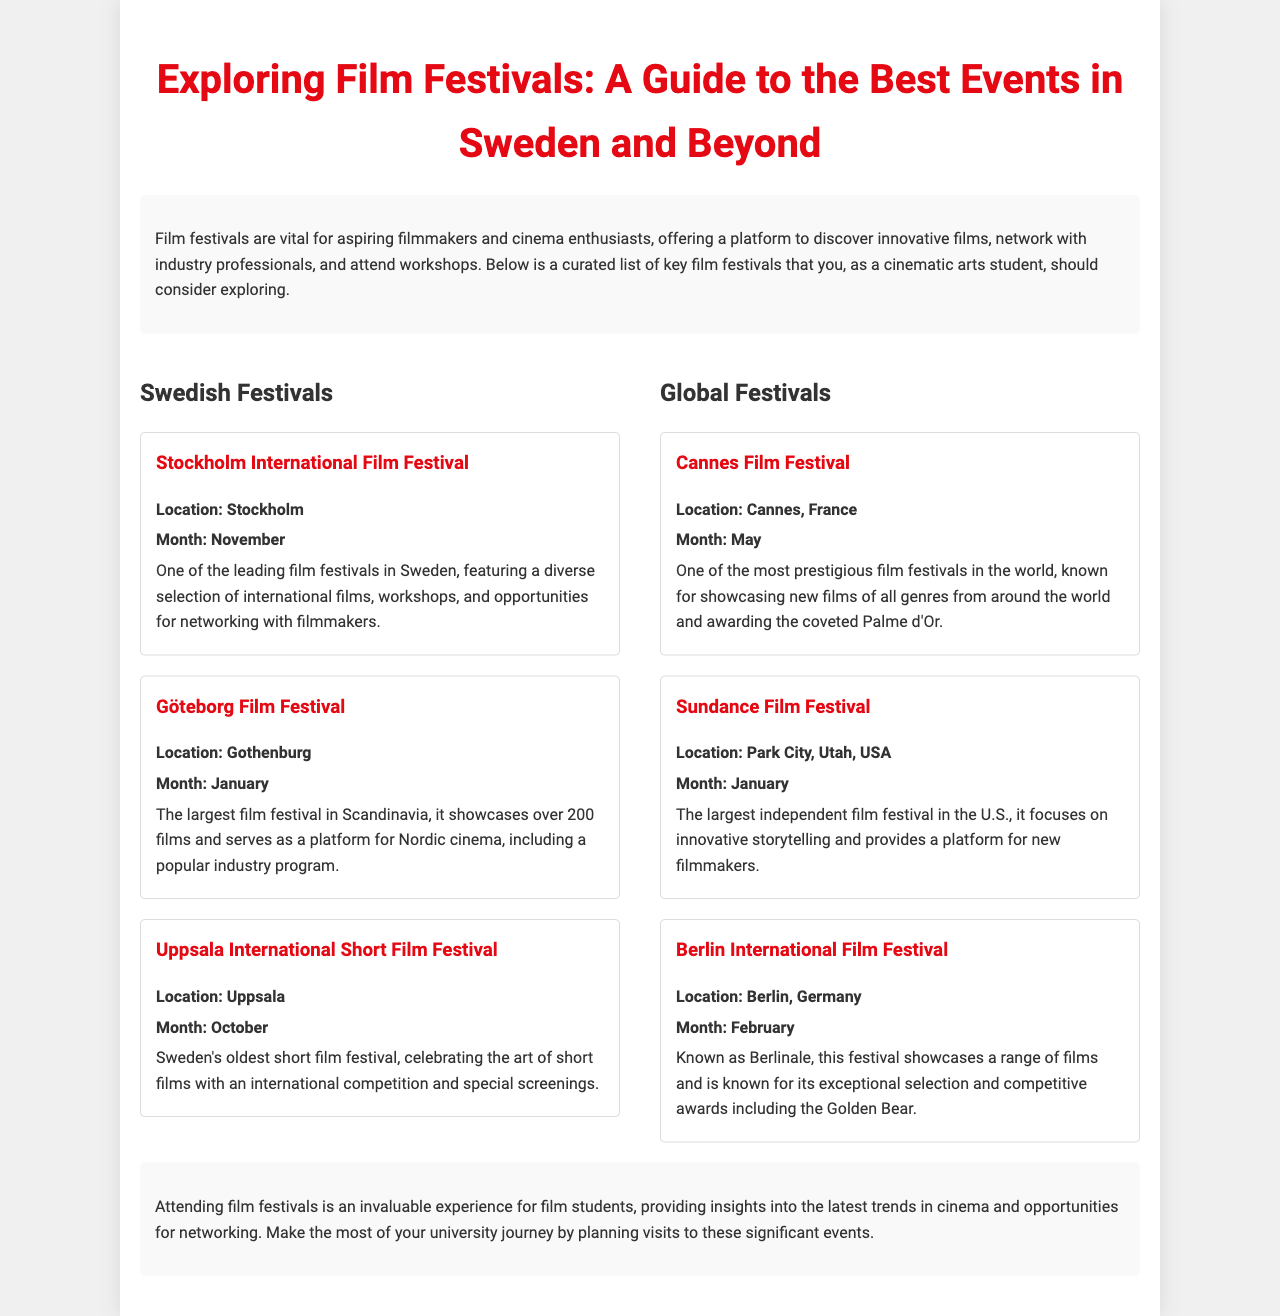What is the title of the guide? The title of the guide is stated prominently at the top of the document.
Answer: Exploring Film Festivals: A Guide to the Best Events in Sweden and Beyond What city hosts the Göteborg Film Festival? The location of the Göteborg Film Festival is mentioned in the festival description.
Answer: Gothenburg In what month does the Uppsala International Short Film Festival take place? The month of the Uppsala International Short Film Festival is listed in the festival details.
Answer: October What prestigious award is associated with the Cannes Film Festival? The award mentioned in relation to the Cannes Film Festival is highlighted within the festival's description.
Answer: Palme d'Or Which festival is noted as the largest film festival in Scandinavia? The largest film festival in Scandinavia is explicitly named in the Swedish Festivals section.
Answer: Göteborg Film Festival Which month features the Berlin International Film Festival? The month is listed alongside the festival information, indicating when it occurs.
Answer: February How many films does the Göteborg Film Festival showcase? The number of films highlighted in the festival description indicates its scale.
Answer: Over 200 What type of films does the Sundance Film Festival focus on? The specific focus of the Sundance Film Festival is mentioned to describe its purpose.
Answer: Innovative storytelling Why should film students attend festivals? The conclusion of the document explains the benefits for film students.
Answer: Networking and insights into cinema trends 